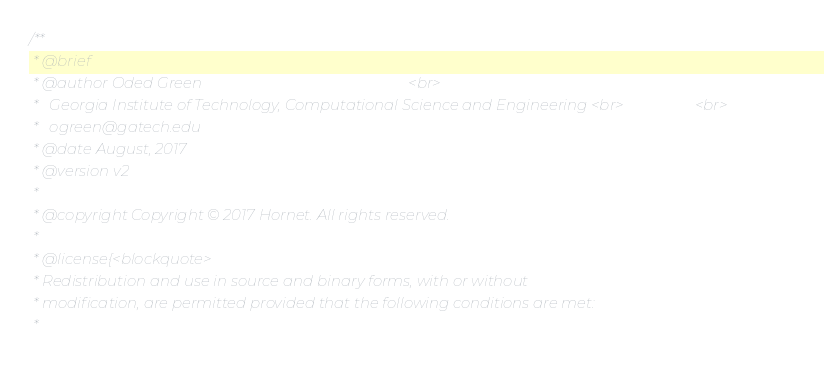Convert code to text. <code><loc_0><loc_0><loc_500><loc_500><_Cuda_>/**
 * @brief
 * @author Oded Green                                                       <br>
 *   Georgia Institute of Technology, Computational Science and Engineering <br>                   <br>
 *   ogreen@gatech.edu
 * @date August, 2017
 * @version v2
 *
 * @copyright Copyright © 2017 Hornet. All rights reserved.
 *
 * @license{<blockquote>
 * Redistribution and use in source and binary forms, with or without
 * modification, are permitted provided that the following conditions are met:
 *</code> 